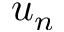<formula> <loc_0><loc_0><loc_500><loc_500>u _ { n }</formula> 